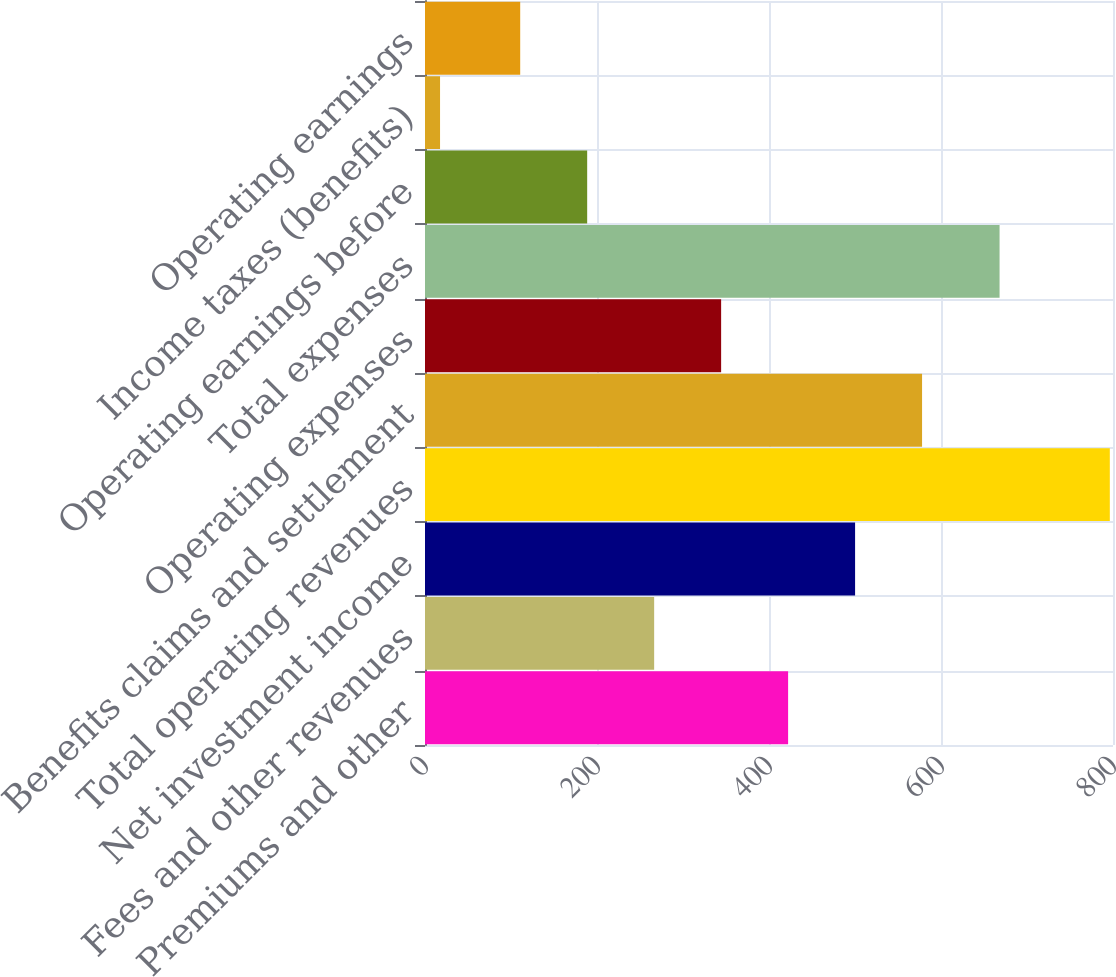Convert chart. <chart><loc_0><loc_0><loc_500><loc_500><bar_chart><fcel>Premiums and other<fcel>Fees and other revenues<fcel>Net investment income<fcel>Total operating revenues<fcel>Benefits claims and settlement<fcel>Operating expenses<fcel>Total expenses<fcel>Operating earnings before<fcel>Income taxes (benefits)<fcel>Operating earnings<nl><fcel>422.22<fcel>266.46<fcel>500.1<fcel>796.3<fcel>577.98<fcel>344.34<fcel>668.1<fcel>188.58<fcel>17.5<fcel>110.7<nl></chart> 